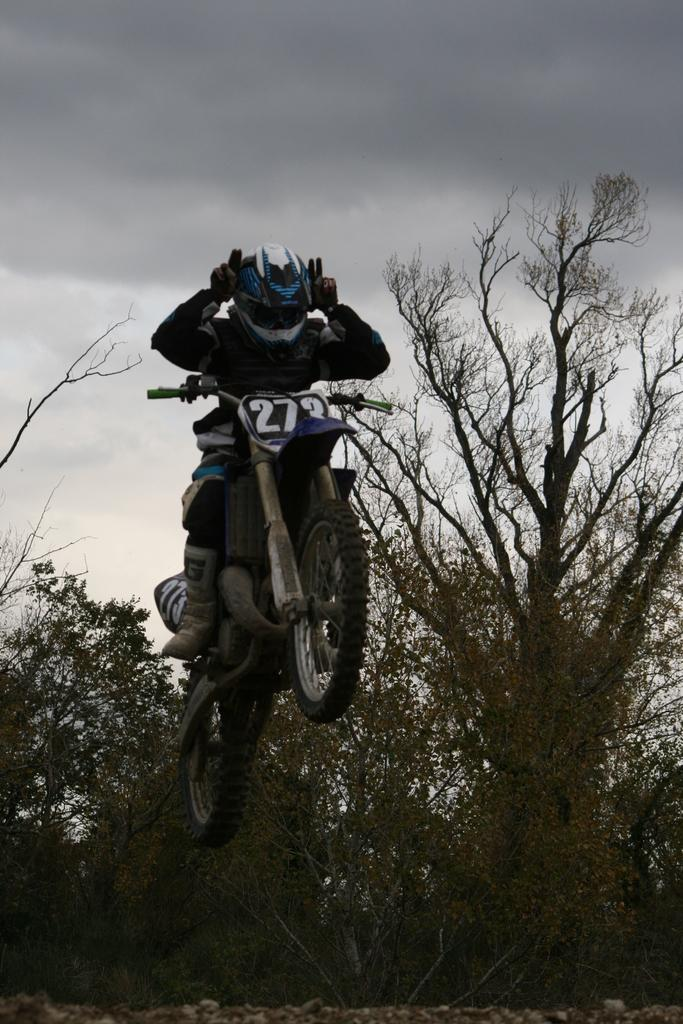What is the main subject of the image? There is a person in the image. What is the person doing in the image? The person is on a motorbike. What can be seen in the background of the image? There are trees and the sky visible in the background of the image. What type of pear is the person holding while riding the motorbike in the image? There is no pear present in the image; the person is riding a motorbike without holding any fruit. 